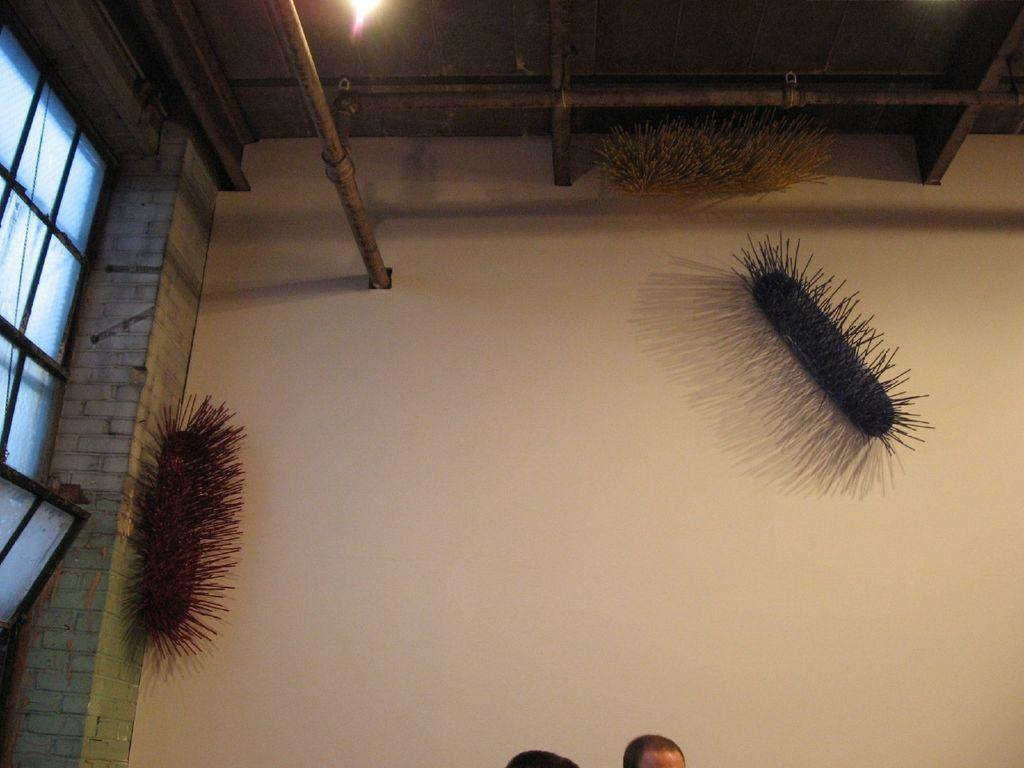How many persons' heads are visible in the image? There are two persons' heads in the image. What can be seen on the wall in the image? There are brushes on the wall. What is located on the roof in the image? There is a light on the roof. What type of opening is present on the left side of the image? There is a glass window on the left side of the image. What type of music can be heard playing in the background of the image? There is no music present in the image, as it is a still image and does not contain any audio. 